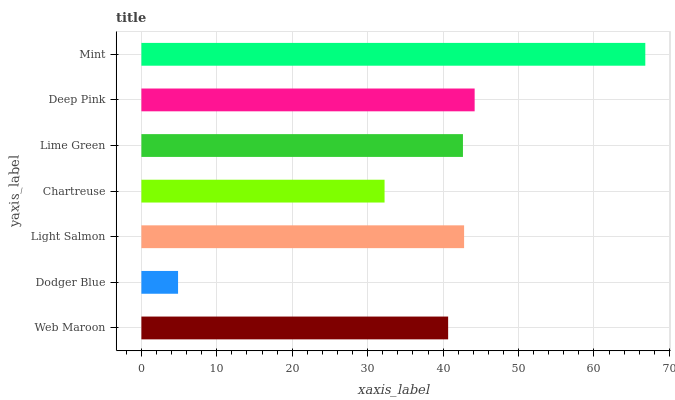Is Dodger Blue the minimum?
Answer yes or no. Yes. Is Mint the maximum?
Answer yes or no. Yes. Is Light Salmon the minimum?
Answer yes or no. No. Is Light Salmon the maximum?
Answer yes or no. No. Is Light Salmon greater than Dodger Blue?
Answer yes or no. Yes. Is Dodger Blue less than Light Salmon?
Answer yes or no. Yes. Is Dodger Blue greater than Light Salmon?
Answer yes or no. No. Is Light Salmon less than Dodger Blue?
Answer yes or no. No. Is Lime Green the high median?
Answer yes or no. Yes. Is Lime Green the low median?
Answer yes or no. Yes. Is Deep Pink the high median?
Answer yes or no. No. Is Mint the low median?
Answer yes or no. No. 